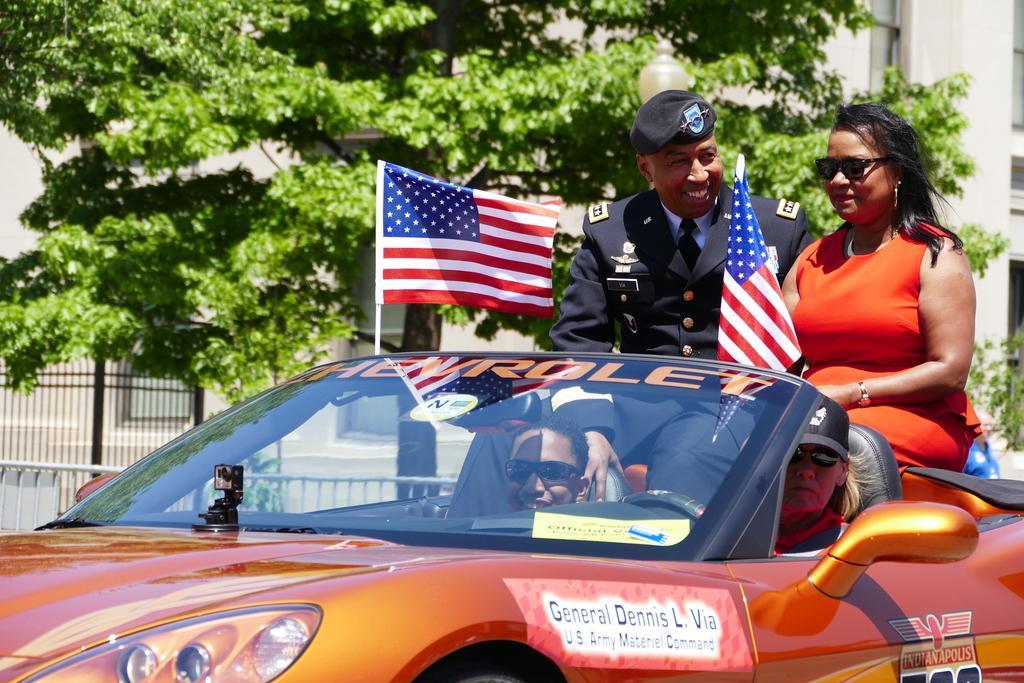Could you give a brief overview of what you see in this image? In a picture there is a orange color car. Inside the card there are two persons sitting in front. And at the back there are two persons sitting. And to the right side there is a lady with orange dress and beside her there is a man with uniform. He is smiling. On the card there is a flag. In the background there is a tree. In the left corner there is a fencing. And we can see a building. 